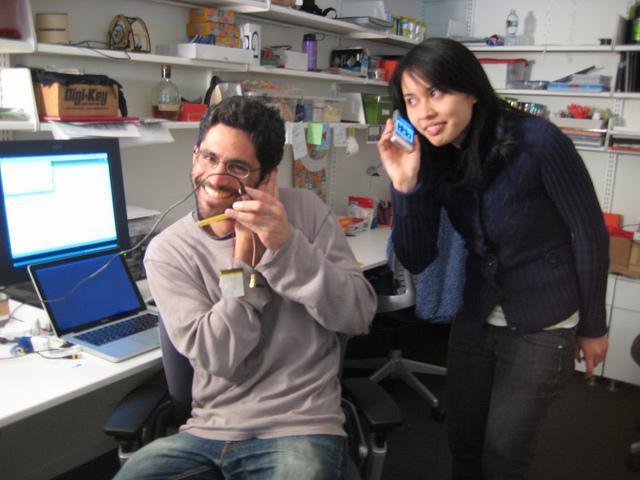How many people have glasses?
Give a very brief answer. 1. How many dictionaries are in the photo?
Give a very brief answer. 0. How many people are there?
Give a very brief answer. 2. How many chairs are there?
Give a very brief answer. 2. How many dogs are on he bench in this image?
Give a very brief answer. 0. 